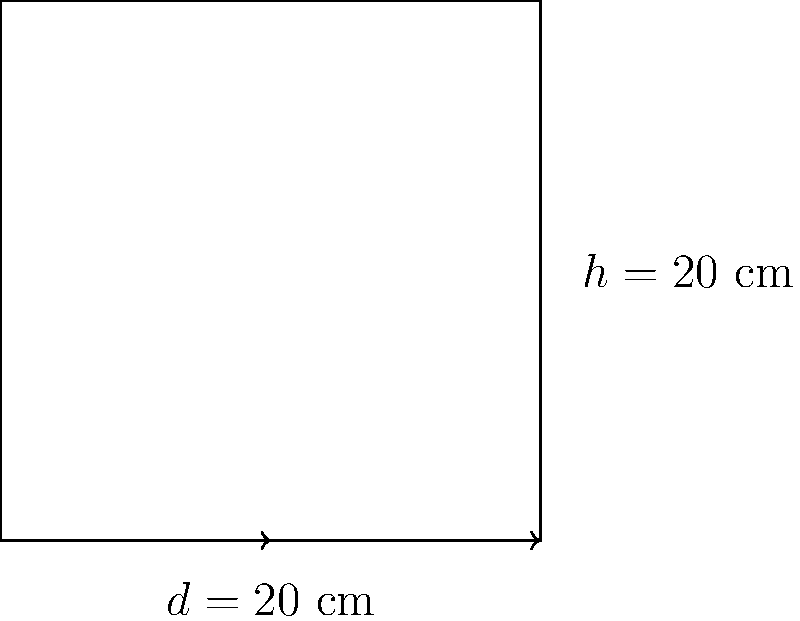Dear friend, I have this lovely cooking pot that brings back such wonderful memories. Its height is 20 cm, and its diameter is also 20 cm. Could you help me calculate the volume of this pot? It would be so nice to know how much of my favorite soup I can make in it. Certainly! Let's calculate the volume of your cherished cooking pot step by step:

1) The pot is cylindrical, so we'll use the formula for the volume of a cylinder:
   $$V = \pi r^2 h$$
   where $V$ is volume, $r$ is the radius of the base, and $h$ is the height.

2) We're given the height $h = 20$ cm and the diameter $d = 20$ cm.

3) To find the radius, we divide the diameter by 2:
   $$r = \frac{d}{2} = \frac{20}{2} = 10\text{ cm}$$

4) Now we can substitute these values into our formula:
   $$V = \pi (10\text{ cm})^2 (20\text{ cm})$$

5) Simplify:
   $$V = \pi (100\text{ cm}^2) (20\text{ cm}) = 2000\pi\text{ cm}^3$$

6) If we want to approximate this in cubic centimeters:
   $$V \approx 2000 \times 3.14159 \approx 6283.18\text{ cm}^3$$

So, your wonderful pot can hold approximately 6,283 cubic centimeters or about 6.3 liters of your delicious soup!
Answer: $2000\pi\text{ cm}^3$ or approximately 6,283 $\text{cm}^3$ 